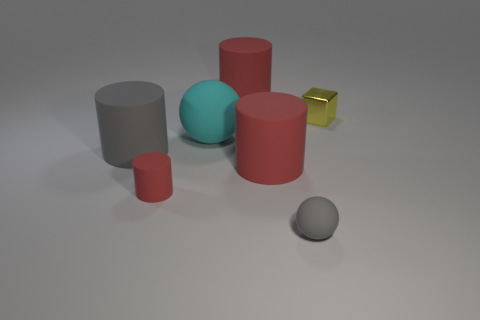The sphere that is to the left of the rubber sphere in front of the small red rubber cylinder is what color?
Provide a short and direct response. Cyan. Is the number of gray matte things greater than the number of purple matte cubes?
Provide a short and direct response. Yes. How many red matte things are the same size as the cyan ball?
Provide a succinct answer. 2. Does the small red thing have the same material as the red thing that is behind the small yellow metal thing?
Provide a short and direct response. Yes. Is the number of shiny cubes less than the number of red matte things?
Provide a succinct answer. Yes. Is there any other thing that is the same color as the metal object?
Provide a succinct answer. No. The tiny red thing that is made of the same material as the gray cylinder is what shape?
Keep it short and to the point. Cylinder. How many metallic objects are to the left of the sphere that is behind the tiny red matte thing that is left of the yellow cube?
Your response must be concise. 0. There is a small object that is both in front of the tiny yellow thing and to the right of the large cyan matte ball; what is its shape?
Make the answer very short. Sphere. Is the number of big red matte cylinders that are behind the yellow cube less than the number of red cylinders?
Provide a succinct answer. Yes. 